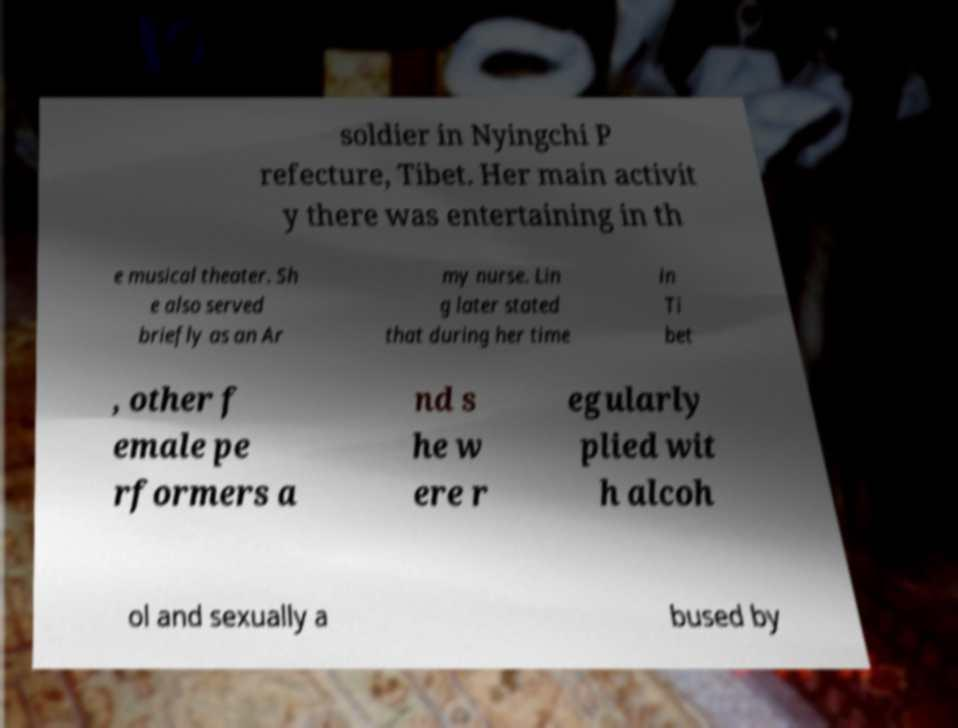Could you assist in decoding the text presented in this image and type it out clearly? soldier in Nyingchi P refecture, Tibet. Her main activit y there was entertaining in th e musical theater. Sh e also served briefly as an Ar my nurse. Lin g later stated that during her time in Ti bet , other f emale pe rformers a nd s he w ere r egularly plied wit h alcoh ol and sexually a bused by 